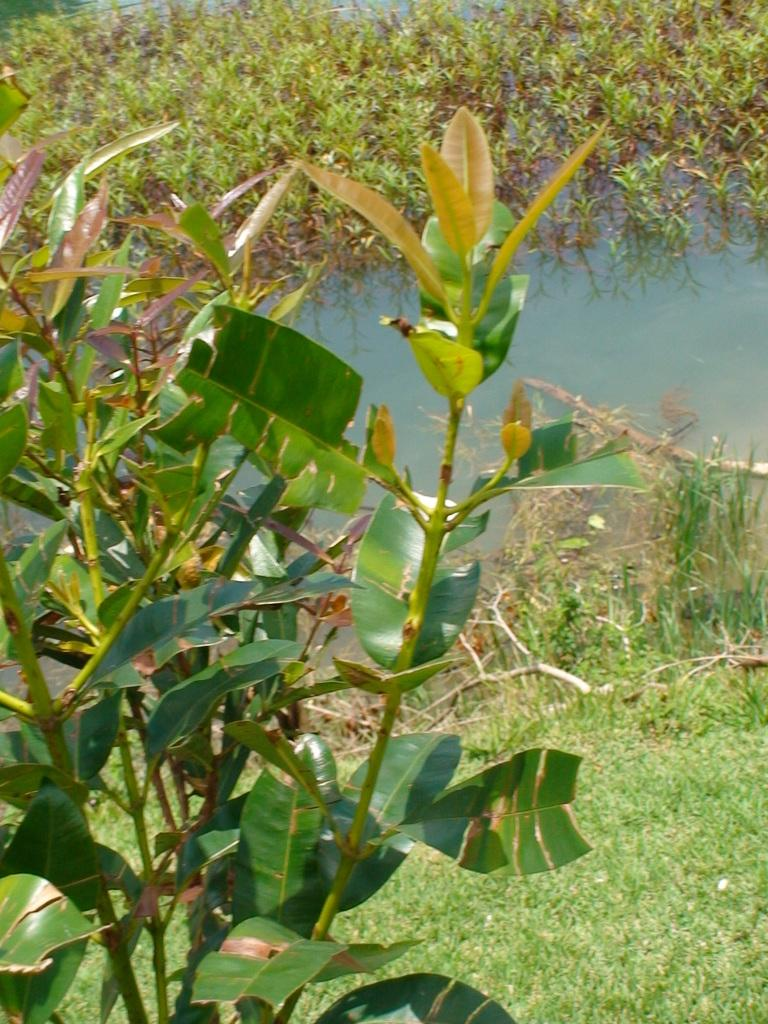What type of vegetation can be seen in the image? There are plants and grass visible in the image. What is the water in the image used for? The water in the image is being used by small plants that are growing in it. Can you describe the setting of the image? The image features plants, grass, and water, suggesting a natural or outdoor setting. Where is the club located in the image? There is no club present in the image. How many babies can be seen playing with the plants in the image? There are no babies present in the image; it features plants, grass, and water. 